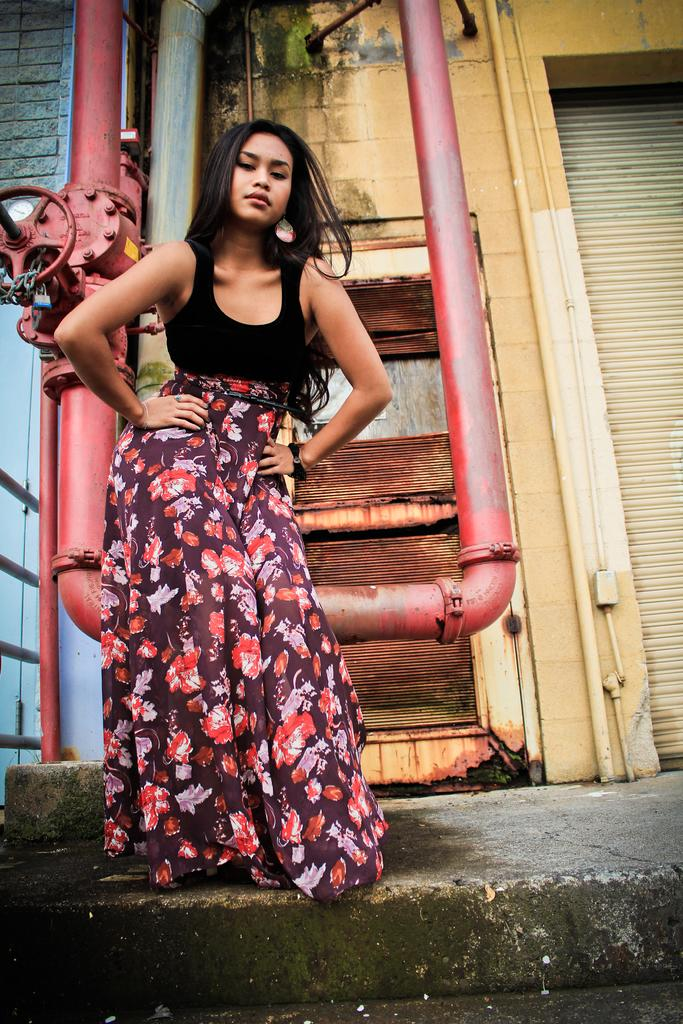Who is present in the image? There is a woman in the image. Where is the woman located? The woman is on the road. What can be seen in the background of the image? There are buildings, metal pipes, and walls in the background of the image. Can you describe the time of day when the image was taken? The image is likely taken during the day, as there is sufficient light to see the details. What type of rabbit is causing the woman to smile in the image? There is no rabbit present in the image, and the woman's expression cannot be determined from the provided facts. 